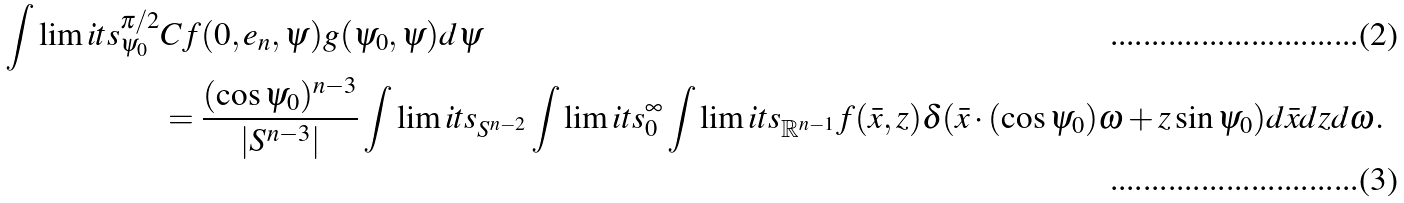<formula> <loc_0><loc_0><loc_500><loc_500>\int \lim i t s _ { \psi _ { 0 } } ^ { \pi / 2 } & C f ( 0 , e _ { n } , \psi ) g ( \psi _ { 0 } , \psi ) d \psi \\ & = \frac { ( \cos \psi _ { 0 } ) ^ { n - 3 } } { | S ^ { n - 3 } | } \int \lim i t s _ { S ^ { n - 2 } } \int \lim i t s _ { 0 } ^ { \infty } \int \lim i t s _ { \mathbb { R } ^ { n - 1 } } f ( \bar { x } , z ) \delta ( \bar { x } \cdot ( \cos \psi _ { 0 } ) \omega + z \sin \psi _ { 0 } ) d \bar { x } d z d \omega .</formula> 